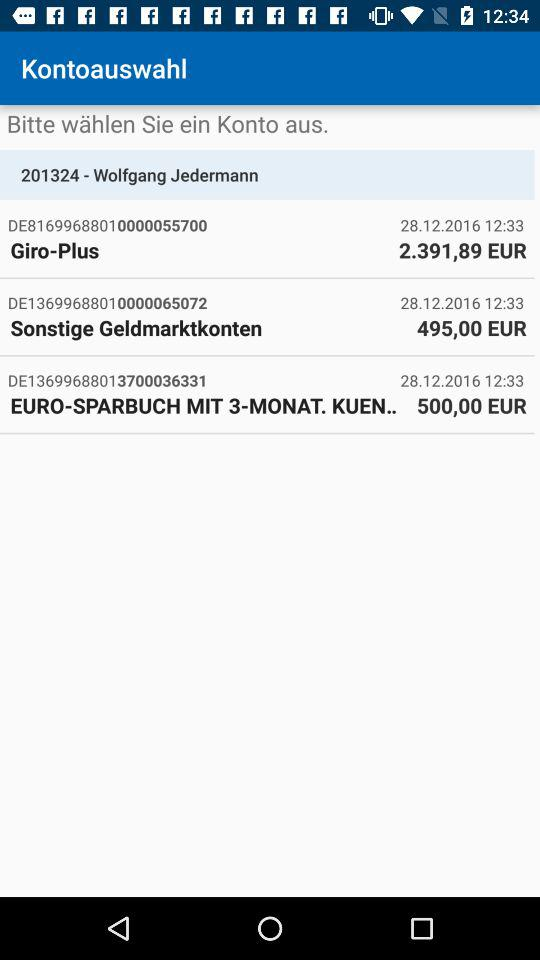How much money is in the EURO-SPARBUCH MIT 3-MONAT. KUEN.. account?
Answer the question using a single word or phrase. 500,00 EUR 